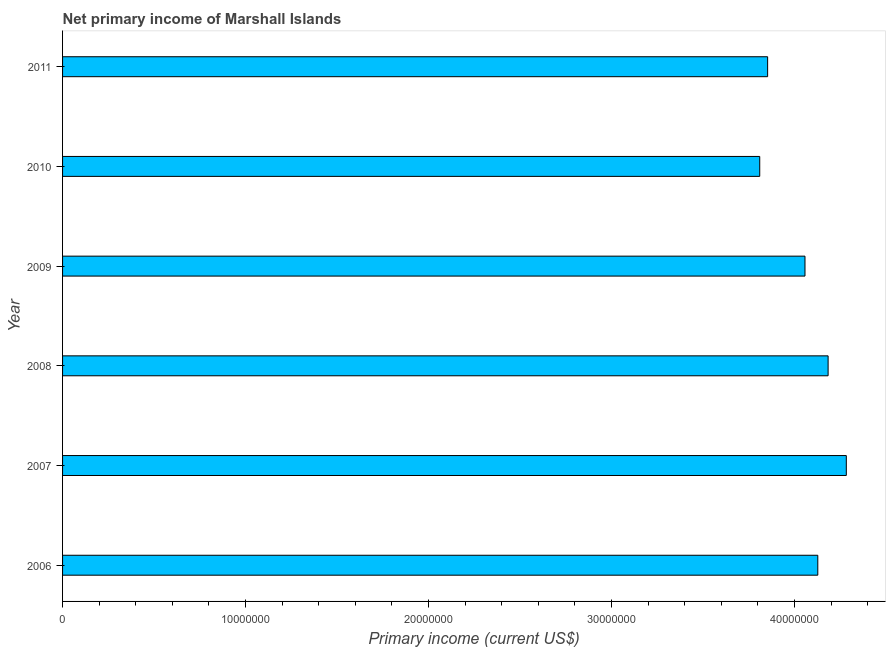Does the graph contain any zero values?
Your answer should be very brief. No. What is the title of the graph?
Offer a terse response. Net primary income of Marshall Islands. What is the label or title of the X-axis?
Give a very brief answer. Primary income (current US$). What is the label or title of the Y-axis?
Offer a terse response. Year. What is the amount of primary income in 2006?
Your response must be concise. 4.13e+07. Across all years, what is the maximum amount of primary income?
Your response must be concise. 4.28e+07. Across all years, what is the minimum amount of primary income?
Your answer should be very brief. 3.81e+07. In which year was the amount of primary income minimum?
Offer a terse response. 2010. What is the sum of the amount of primary income?
Your answer should be very brief. 2.43e+08. What is the difference between the amount of primary income in 2008 and 2009?
Your answer should be very brief. 1.26e+06. What is the average amount of primary income per year?
Give a very brief answer. 4.05e+07. What is the median amount of primary income?
Provide a short and direct response. 4.09e+07. In how many years, is the amount of primary income greater than 8000000 US$?
Provide a short and direct response. 6. What is the difference between the highest and the second highest amount of primary income?
Offer a very short reply. 9.94e+05. Is the sum of the amount of primary income in 2006 and 2011 greater than the maximum amount of primary income across all years?
Provide a succinct answer. Yes. What is the difference between the highest and the lowest amount of primary income?
Your answer should be very brief. 4.73e+06. In how many years, is the amount of primary income greater than the average amount of primary income taken over all years?
Your answer should be very brief. 4. Are all the bars in the graph horizontal?
Offer a very short reply. Yes. Are the values on the major ticks of X-axis written in scientific E-notation?
Keep it short and to the point. No. What is the Primary income (current US$) in 2006?
Your answer should be very brief. 4.13e+07. What is the Primary income (current US$) in 2007?
Provide a short and direct response. 4.28e+07. What is the Primary income (current US$) of 2008?
Provide a short and direct response. 4.18e+07. What is the Primary income (current US$) in 2009?
Provide a succinct answer. 4.06e+07. What is the Primary income (current US$) in 2010?
Offer a terse response. 3.81e+07. What is the Primary income (current US$) of 2011?
Keep it short and to the point. 3.85e+07. What is the difference between the Primary income (current US$) in 2006 and 2007?
Provide a succinct answer. -1.56e+06. What is the difference between the Primary income (current US$) in 2006 and 2008?
Your response must be concise. -5.64e+05. What is the difference between the Primary income (current US$) in 2006 and 2009?
Ensure brevity in your answer.  7.00e+05. What is the difference between the Primary income (current US$) in 2006 and 2010?
Give a very brief answer. 3.17e+06. What is the difference between the Primary income (current US$) in 2006 and 2011?
Offer a very short reply. 2.74e+06. What is the difference between the Primary income (current US$) in 2007 and 2008?
Your answer should be compact. 9.94e+05. What is the difference between the Primary income (current US$) in 2007 and 2009?
Provide a short and direct response. 2.26e+06. What is the difference between the Primary income (current US$) in 2007 and 2010?
Give a very brief answer. 4.73e+06. What is the difference between the Primary income (current US$) in 2007 and 2011?
Offer a terse response. 4.30e+06. What is the difference between the Primary income (current US$) in 2008 and 2009?
Provide a succinct answer. 1.26e+06. What is the difference between the Primary income (current US$) in 2008 and 2010?
Your answer should be compact. 3.74e+06. What is the difference between the Primary income (current US$) in 2008 and 2011?
Keep it short and to the point. 3.31e+06. What is the difference between the Primary income (current US$) in 2009 and 2010?
Provide a succinct answer. 2.47e+06. What is the difference between the Primary income (current US$) in 2009 and 2011?
Keep it short and to the point. 2.04e+06. What is the difference between the Primary income (current US$) in 2010 and 2011?
Your answer should be very brief. -4.31e+05. What is the ratio of the Primary income (current US$) in 2006 to that in 2007?
Make the answer very short. 0.96. What is the ratio of the Primary income (current US$) in 2006 to that in 2010?
Give a very brief answer. 1.08. What is the ratio of the Primary income (current US$) in 2006 to that in 2011?
Ensure brevity in your answer.  1.07. What is the ratio of the Primary income (current US$) in 2007 to that in 2008?
Provide a succinct answer. 1.02. What is the ratio of the Primary income (current US$) in 2007 to that in 2009?
Your answer should be compact. 1.06. What is the ratio of the Primary income (current US$) in 2007 to that in 2010?
Your response must be concise. 1.12. What is the ratio of the Primary income (current US$) in 2007 to that in 2011?
Your response must be concise. 1.11. What is the ratio of the Primary income (current US$) in 2008 to that in 2009?
Make the answer very short. 1.03. What is the ratio of the Primary income (current US$) in 2008 to that in 2010?
Provide a succinct answer. 1.1. What is the ratio of the Primary income (current US$) in 2008 to that in 2011?
Your answer should be compact. 1.09. What is the ratio of the Primary income (current US$) in 2009 to that in 2010?
Your response must be concise. 1.06. What is the ratio of the Primary income (current US$) in 2009 to that in 2011?
Your response must be concise. 1.05. 